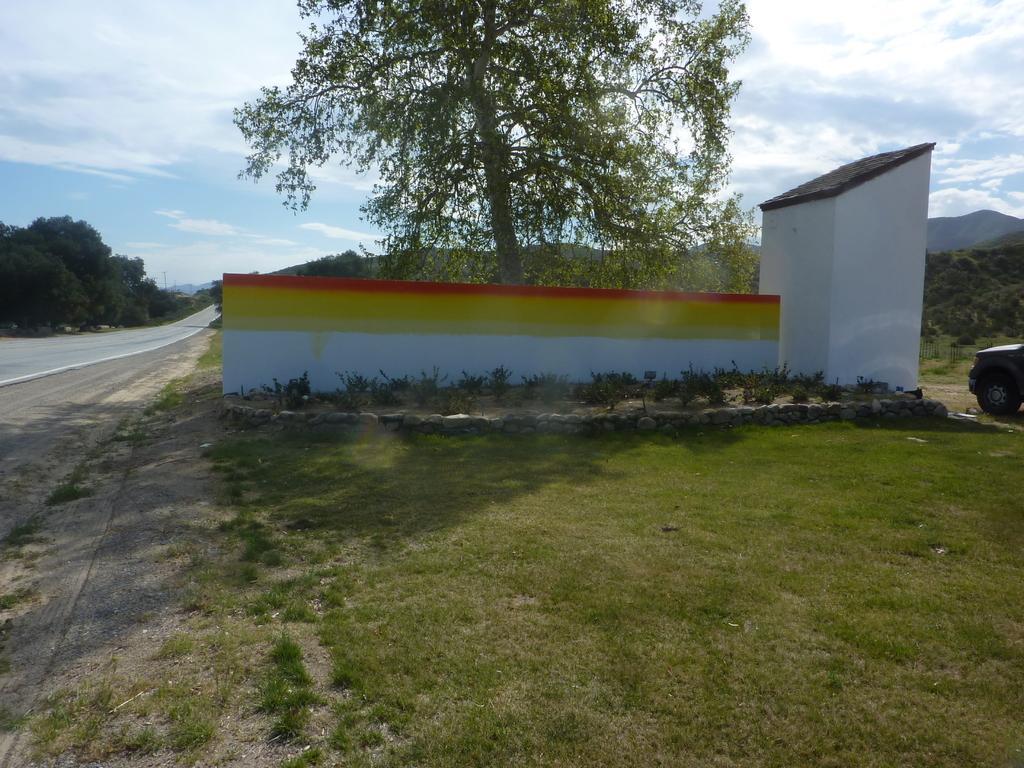Could you give a brief overview of what you see in this image? In this image we can see a shed, trees, sky with clouds, road, motor vehicle, shrubs, stones and ground. 